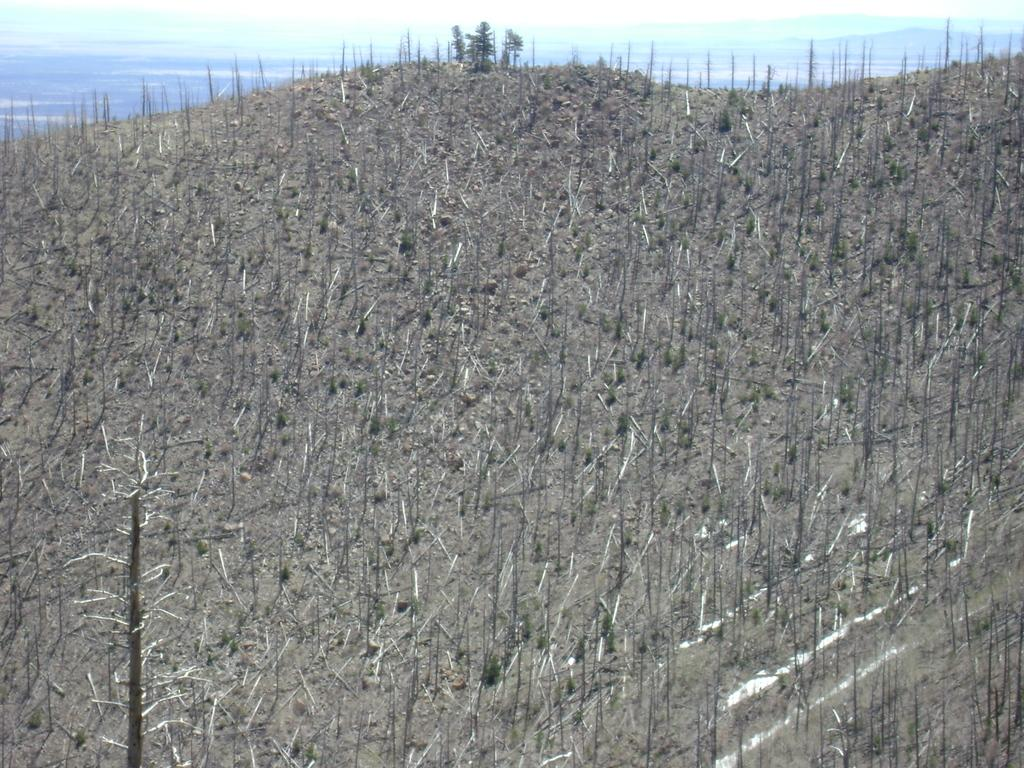What type of vegetation is present in the image? There are dried plants and dried trees in the image. What can be seen in the background of the image? There are mountains and the sky visible in the background of the image. How many yaks are present in the image? There are no yaks present in the image. What team is responsible for maintaining the dried plants in the image? There is no team mentioned or implied in the image, as it only features dried plants and trees, mountains, and the sky. 